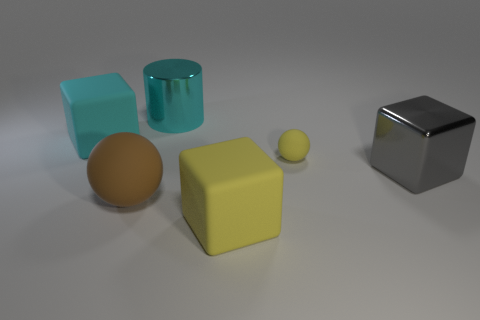What is the size of the rubber cube that is the same color as the big shiny cylinder?
Offer a terse response. Large. What material is the large yellow block?
Your answer should be compact. Rubber. Are the large gray object and the large cube that is to the left of the brown thing made of the same material?
Offer a very short reply. No. The block behind the big gray metal thing right of the cyan metal thing is what color?
Offer a terse response. Cyan. There is a cube that is to the left of the large gray shiny object and right of the large brown thing; what is its size?
Offer a very short reply. Large. What number of other objects are there of the same shape as the small yellow matte object?
Provide a succinct answer. 1. There is a large gray metal thing; is it the same shape as the rubber object that is in front of the brown ball?
Offer a terse response. Yes. What number of yellow matte things are to the right of the cyan metal cylinder?
Your response must be concise. 2. There is a yellow thing that is behind the big yellow cube; is its shape the same as the large brown object?
Make the answer very short. Yes. What color is the big shiny thing that is in front of the large cylinder?
Offer a terse response. Gray. 